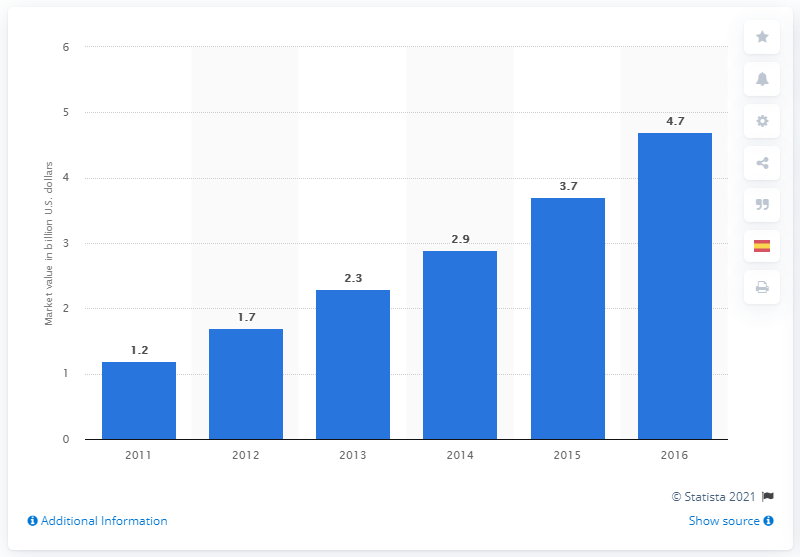Mention a couple of crucial points in this snapshot. The estimated market value of the residential solar photovoltaic industry in 2012 was 2.3 billion dollars. The highest and lowest bars in the graph correspond to the values 3.5 and 2.0, respectively. The lowest value in the blue bar is 1.2. 